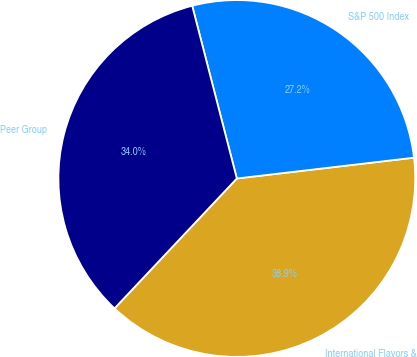Convert chart to OTSL. <chart><loc_0><loc_0><loc_500><loc_500><pie_chart><fcel>International Flavors &<fcel>S&P 500 Index<fcel>Peer Group<nl><fcel>38.88%<fcel>27.16%<fcel>33.95%<nl></chart> 